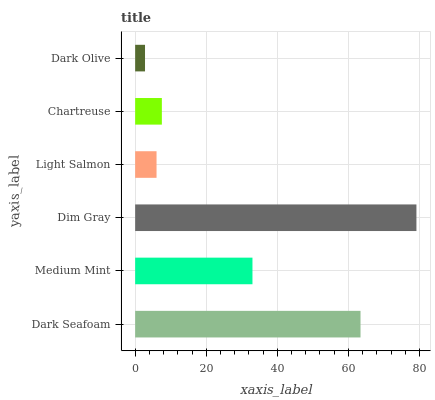Is Dark Olive the minimum?
Answer yes or no. Yes. Is Dim Gray the maximum?
Answer yes or no. Yes. Is Medium Mint the minimum?
Answer yes or no. No. Is Medium Mint the maximum?
Answer yes or no. No. Is Dark Seafoam greater than Medium Mint?
Answer yes or no. Yes. Is Medium Mint less than Dark Seafoam?
Answer yes or no. Yes. Is Medium Mint greater than Dark Seafoam?
Answer yes or no. No. Is Dark Seafoam less than Medium Mint?
Answer yes or no. No. Is Medium Mint the high median?
Answer yes or no. Yes. Is Chartreuse the low median?
Answer yes or no. Yes. Is Chartreuse the high median?
Answer yes or no. No. Is Light Salmon the low median?
Answer yes or no. No. 